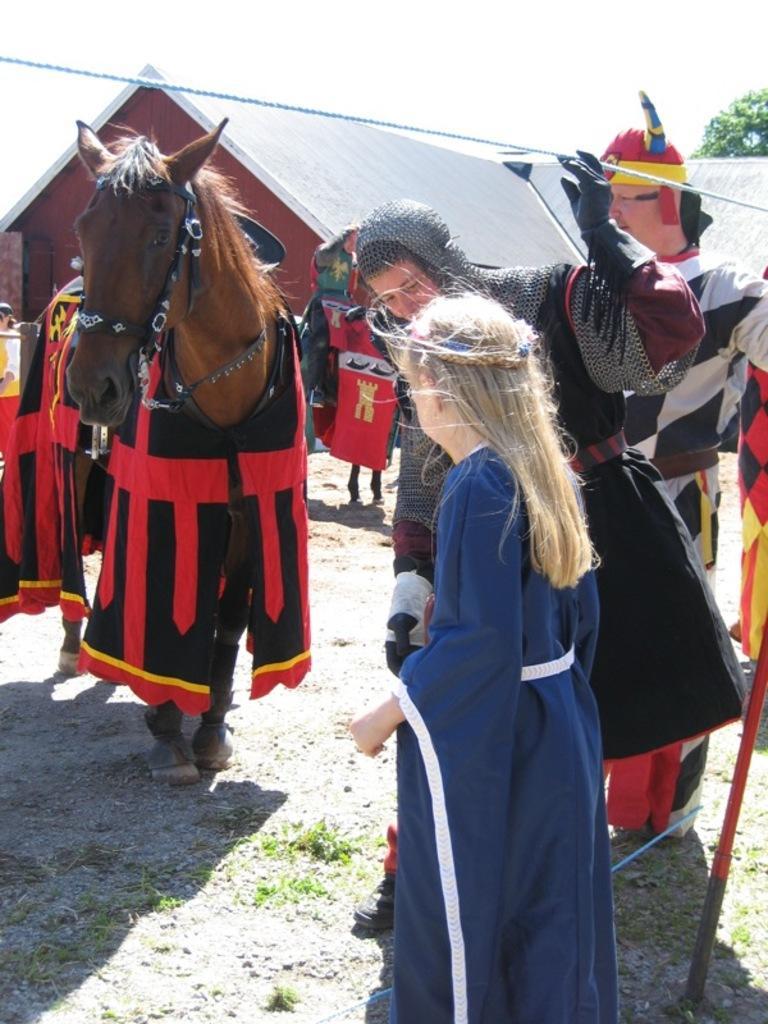Describe this image in one or two sentences. In this image we can see there is a horse on the ground and there are clothes on it. And there are people standing on the ground. And there is a house, tree, rope, stick and the sky. 